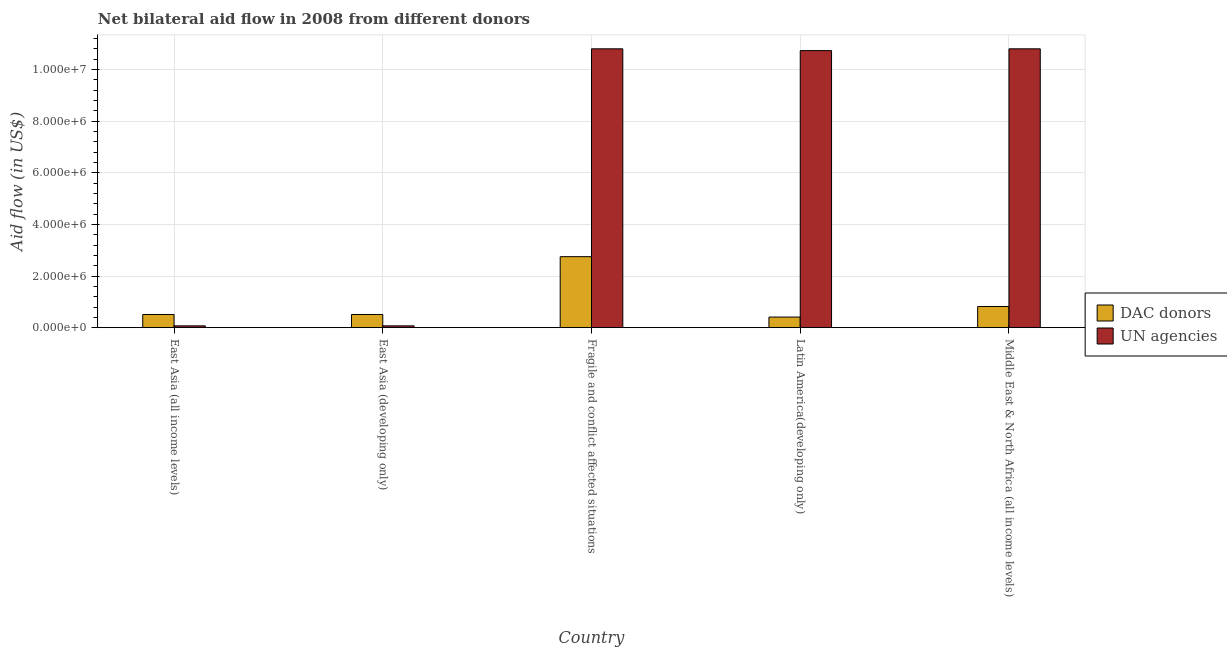How many different coloured bars are there?
Offer a very short reply. 2. Are the number of bars per tick equal to the number of legend labels?
Offer a terse response. Yes. Are the number of bars on each tick of the X-axis equal?
Give a very brief answer. Yes. How many bars are there on the 3rd tick from the left?
Your response must be concise. 2. What is the label of the 1st group of bars from the left?
Provide a short and direct response. East Asia (all income levels). What is the aid flow from un agencies in Latin America(developing only)?
Ensure brevity in your answer.  1.07e+07. Across all countries, what is the maximum aid flow from dac donors?
Your response must be concise. 2.75e+06. Across all countries, what is the minimum aid flow from un agencies?
Provide a short and direct response. 7.00e+04. In which country was the aid flow from un agencies maximum?
Offer a very short reply. Fragile and conflict affected situations. In which country was the aid flow from dac donors minimum?
Your answer should be very brief. Latin America(developing only). What is the total aid flow from un agencies in the graph?
Your response must be concise. 3.25e+07. What is the difference between the aid flow from un agencies in East Asia (all income levels) and that in Fragile and conflict affected situations?
Offer a terse response. -1.07e+07. What is the difference between the aid flow from un agencies in East Asia (developing only) and the aid flow from dac donors in East Asia (all income levels)?
Offer a very short reply. -4.40e+05. What is the average aid flow from un agencies per country?
Give a very brief answer. 6.49e+06. What is the difference between the aid flow from un agencies and aid flow from dac donors in Fragile and conflict affected situations?
Keep it short and to the point. 8.05e+06. What is the ratio of the aid flow from un agencies in East Asia (developing only) to that in Latin America(developing only)?
Provide a succinct answer. 0.01. Is the aid flow from un agencies in East Asia (all income levels) less than that in Fragile and conflict affected situations?
Your answer should be compact. Yes. Is the difference between the aid flow from un agencies in East Asia (all income levels) and Middle East & North Africa (all income levels) greater than the difference between the aid flow from dac donors in East Asia (all income levels) and Middle East & North Africa (all income levels)?
Give a very brief answer. No. What is the difference between the highest and the lowest aid flow from un agencies?
Provide a short and direct response. 1.07e+07. In how many countries, is the aid flow from un agencies greater than the average aid flow from un agencies taken over all countries?
Provide a succinct answer. 3. What does the 1st bar from the left in East Asia (developing only) represents?
Provide a succinct answer. DAC donors. What does the 1st bar from the right in Fragile and conflict affected situations represents?
Your answer should be compact. UN agencies. How many bars are there?
Offer a terse response. 10. Are all the bars in the graph horizontal?
Ensure brevity in your answer.  No. Where does the legend appear in the graph?
Ensure brevity in your answer.  Center right. What is the title of the graph?
Provide a succinct answer. Net bilateral aid flow in 2008 from different donors. What is the label or title of the Y-axis?
Give a very brief answer. Aid flow (in US$). What is the Aid flow (in US$) of DAC donors in East Asia (all income levels)?
Provide a short and direct response. 5.10e+05. What is the Aid flow (in US$) of UN agencies in East Asia (all income levels)?
Offer a terse response. 7.00e+04. What is the Aid flow (in US$) in DAC donors in East Asia (developing only)?
Give a very brief answer. 5.10e+05. What is the Aid flow (in US$) of DAC donors in Fragile and conflict affected situations?
Your response must be concise. 2.75e+06. What is the Aid flow (in US$) of UN agencies in Fragile and conflict affected situations?
Offer a very short reply. 1.08e+07. What is the Aid flow (in US$) in DAC donors in Latin America(developing only)?
Your response must be concise. 4.10e+05. What is the Aid flow (in US$) of UN agencies in Latin America(developing only)?
Make the answer very short. 1.07e+07. What is the Aid flow (in US$) of DAC donors in Middle East & North Africa (all income levels)?
Keep it short and to the point. 8.20e+05. What is the Aid flow (in US$) in UN agencies in Middle East & North Africa (all income levels)?
Make the answer very short. 1.08e+07. Across all countries, what is the maximum Aid flow (in US$) of DAC donors?
Your response must be concise. 2.75e+06. Across all countries, what is the maximum Aid flow (in US$) in UN agencies?
Your answer should be very brief. 1.08e+07. Across all countries, what is the minimum Aid flow (in US$) in UN agencies?
Provide a short and direct response. 7.00e+04. What is the total Aid flow (in US$) in UN agencies in the graph?
Keep it short and to the point. 3.25e+07. What is the difference between the Aid flow (in US$) of DAC donors in East Asia (all income levels) and that in East Asia (developing only)?
Ensure brevity in your answer.  0. What is the difference between the Aid flow (in US$) in DAC donors in East Asia (all income levels) and that in Fragile and conflict affected situations?
Offer a very short reply. -2.24e+06. What is the difference between the Aid flow (in US$) of UN agencies in East Asia (all income levels) and that in Fragile and conflict affected situations?
Offer a terse response. -1.07e+07. What is the difference between the Aid flow (in US$) in UN agencies in East Asia (all income levels) and that in Latin America(developing only)?
Your answer should be compact. -1.07e+07. What is the difference between the Aid flow (in US$) in DAC donors in East Asia (all income levels) and that in Middle East & North Africa (all income levels)?
Keep it short and to the point. -3.10e+05. What is the difference between the Aid flow (in US$) in UN agencies in East Asia (all income levels) and that in Middle East & North Africa (all income levels)?
Make the answer very short. -1.07e+07. What is the difference between the Aid flow (in US$) of DAC donors in East Asia (developing only) and that in Fragile and conflict affected situations?
Keep it short and to the point. -2.24e+06. What is the difference between the Aid flow (in US$) in UN agencies in East Asia (developing only) and that in Fragile and conflict affected situations?
Give a very brief answer. -1.07e+07. What is the difference between the Aid flow (in US$) in DAC donors in East Asia (developing only) and that in Latin America(developing only)?
Offer a very short reply. 1.00e+05. What is the difference between the Aid flow (in US$) of UN agencies in East Asia (developing only) and that in Latin America(developing only)?
Your answer should be very brief. -1.07e+07. What is the difference between the Aid flow (in US$) in DAC donors in East Asia (developing only) and that in Middle East & North Africa (all income levels)?
Your answer should be compact. -3.10e+05. What is the difference between the Aid flow (in US$) of UN agencies in East Asia (developing only) and that in Middle East & North Africa (all income levels)?
Provide a short and direct response. -1.07e+07. What is the difference between the Aid flow (in US$) of DAC donors in Fragile and conflict affected situations and that in Latin America(developing only)?
Provide a short and direct response. 2.34e+06. What is the difference between the Aid flow (in US$) in DAC donors in Fragile and conflict affected situations and that in Middle East & North Africa (all income levels)?
Keep it short and to the point. 1.93e+06. What is the difference between the Aid flow (in US$) in UN agencies in Fragile and conflict affected situations and that in Middle East & North Africa (all income levels)?
Your answer should be compact. 0. What is the difference between the Aid flow (in US$) of DAC donors in Latin America(developing only) and that in Middle East & North Africa (all income levels)?
Offer a terse response. -4.10e+05. What is the difference between the Aid flow (in US$) of UN agencies in Latin America(developing only) and that in Middle East & North Africa (all income levels)?
Provide a succinct answer. -7.00e+04. What is the difference between the Aid flow (in US$) in DAC donors in East Asia (all income levels) and the Aid flow (in US$) in UN agencies in Fragile and conflict affected situations?
Keep it short and to the point. -1.03e+07. What is the difference between the Aid flow (in US$) in DAC donors in East Asia (all income levels) and the Aid flow (in US$) in UN agencies in Latin America(developing only)?
Provide a succinct answer. -1.02e+07. What is the difference between the Aid flow (in US$) in DAC donors in East Asia (all income levels) and the Aid flow (in US$) in UN agencies in Middle East & North Africa (all income levels)?
Provide a succinct answer. -1.03e+07. What is the difference between the Aid flow (in US$) in DAC donors in East Asia (developing only) and the Aid flow (in US$) in UN agencies in Fragile and conflict affected situations?
Your answer should be very brief. -1.03e+07. What is the difference between the Aid flow (in US$) of DAC donors in East Asia (developing only) and the Aid flow (in US$) of UN agencies in Latin America(developing only)?
Your response must be concise. -1.02e+07. What is the difference between the Aid flow (in US$) in DAC donors in East Asia (developing only) and the Aid flow (in US$) in UN agencies in Middle East & North Africa (all income levels)?
Keep it short and to the point. -1.03e+07. What is the difference between the Aid flow (in US$) in DAC donors in Fragile and conflict affected situations and the Aid flow (in US$) in UN agencies in Latin America(developing only)?
Make the answer very short. -7.98e+06. What is the difference between the Aid flow (in US$) in DAC donors in Fragile and conflict affected situations and the Aid flow (in US$) in UN agencies in Middle East & North Africa (all income levels)?
Ensure brevity in your answer.  -8.05e+06. What is the difference between the Aid flow (in US$) in DAC donors in Latin America(developing only) and the Aid flow (in US$) in UN agencies in Middle East & North Africa (all income levels)?
Provide a succinct answer. -1.04e+07. What is the average Aid flow (in US$) in DAC donors per country?
Offer a terse response. 1.00e+06. What is the average Aid flow (in US$) in UN agencies per country?
Provide a succinct answer. 6.49e+06. What is the difference between the Aid flow (in US$) of DAC donors and Aid flow (in US$) of UN agencies in Fragile and conflict affected situations?
Your answer should be very brief. -8.05e+06. What is the difference between the Aid flow (in US$) of DAC donors and Aid flow (in US$) of UN agencies in Latin America(developing only)?
Your answer should be compact. -1.03e+07. What is the difference between the Aid flow (in US$) of DAC donors and Aid flow (in US$) of UN agencies in Middle East & North Africa (all income levels)?
Give a very brief answer. -9.98e+06. What is the ratio of the Aid flow (in US$) of UN agencies in East Asia (all income levels) to that in East Asia (developing only)?
Keep it short and to the point. 1. What is the ratio of the Aid flow (in US$) of DAC donors in East Asia (all income levels) to that in Fragile and conflict affected situations?
Provide a succinct answer. 0.19. What is the ratio of the Aid flow (in US$) in UN agencies in East Asia (all income levels) to that in Fragile and conflict affected situations?
Your answer should be compact. 0.01. What is the ratio of the Aid flow (in US$) of DAC donors in East Asia (all income levels) to that in Latin America(developing only)?
Offer a very short reply. 1.24. What is the ratio of the Aid flow (in US$) in UN agencies in East Asia (all income levels) to that in Latin America(developing only)?
Your answer should be compact. 0.01. What is the ratio of the Aid flow (in US$) of DAC donors in East Asia (all income levels) to that in Middle East & North Africa (all income levels)?
Provide a short and direct response. 0.62. What is the ratio of the Aid flow (in US$) of UN agencies in East Asia (all income levels) to that in Middle East & North Africa (all income levels)?
Make the answer very short. 0.01. What is the ratio of the Aid flow (in US$) in DAC donors in East Asia (developing only) to that in Fragile and conflict affected situations?
Your response must be concise. 0.19. What is the ratio of the Aid flow (in US$) in UN agencies in East Asia (developing only) to that in Fragile and conflict affected situations?
Make the answer very short. 0.01. What is the ratio of the Aid flow (in US$) of DAC donors in East Asia (developing only) to that in Latin America(developing only)?
Your response must be concise. 1.24. What is the ratio of the Aid flow (in US$) of UN agencies in East Asia (developing only) to that in Latin America(developing only)?
Keep it short and to the point. 0.01. What is the ratio of the Aid flow (in US$) in DAC donors in East Asia (developing only) to that in Middle East & North Africa (all income levels)?
Provide a succinct answer. 0.62. What is the ratio of the Aid flow (in US$) of UN agencies in East Asia (developing only) to that in Middle East & North Africa (all income levels)?
Give a very brief answer. 0.01. What is the ratio of the Aid flow (in US$) of DAC donors in Fragile and conflict affected situations to that in Latin America(developing only)?
Your answer should be very brief. 6.71. What is the ratio of the Aid flow (in US$) of UN agencies in Fragile and conflict affected situations to that in Latin America(developing only)?
Your answer should be very brief. 1.01. What is the ratio of the Aid flow (in US$) in DAC donors in Fragile and conflict affected situations to that in Middle East & North Africa (all income levels)?
Offer a terse response. 3.35. What is the ratio of the Aid flow (in US$) in UN agencies in Fragile and conflict affected situations to that in Middle East & North Africa (all income levels)?
Offer a very short reply. 1. What is the ratio of the Aid flow (in US$) in DAC donors in Latin America(developing only) to that in Middle East & North Africa (all income levels)?
Your answer should be very brief. 0.5. What is the ratio of the Aid flow (in US$) of UN agencies in Latin America(developing only) to that in Middle East & North Africa (all income levels)?
Keep it short and to the point. 0.99. What is the difference between the highest and the second highest Aid flow (in US$) of DAC donors?
Provide a short and direct response. 1.93e+06. What is the difference between the highest and the second highest Aid flow (in US$) in UN agencies?
Offer a terse response. 0. What is the difference between the highest and the lowest Aid flow (in US$) in DAC donors?
Your response must be concise. 2.34e+06. What is the difference between the highest and the lowest Aid flow (in US$) of UN agencies?
Provide a short and direct response. 1.07e+07. 